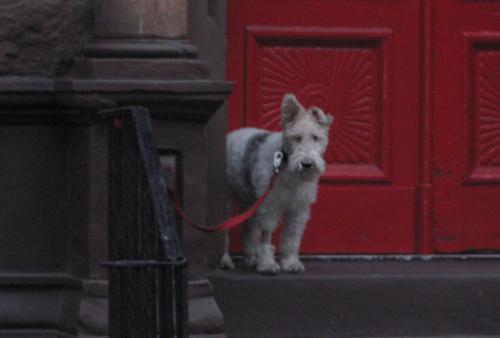How many dogs are there?
Give a very brief answer. 1. How many people are fully visible?
Give a very brief answer. 0. 